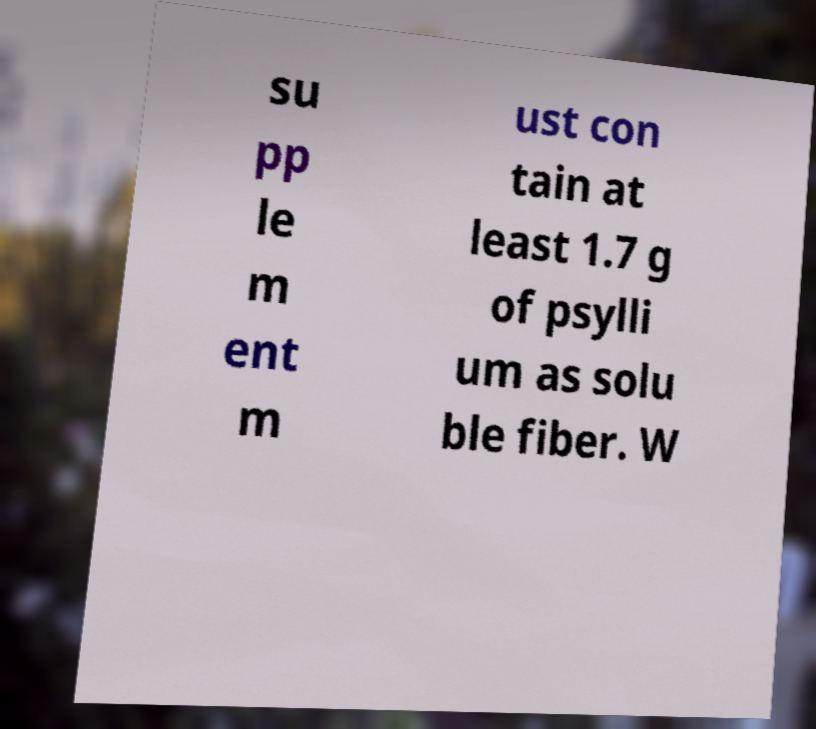Please identify and transcribe the text found in this image. su pp le m ent m ust con tain at least 1.7 g of psylli um as solu ble fiber. W 